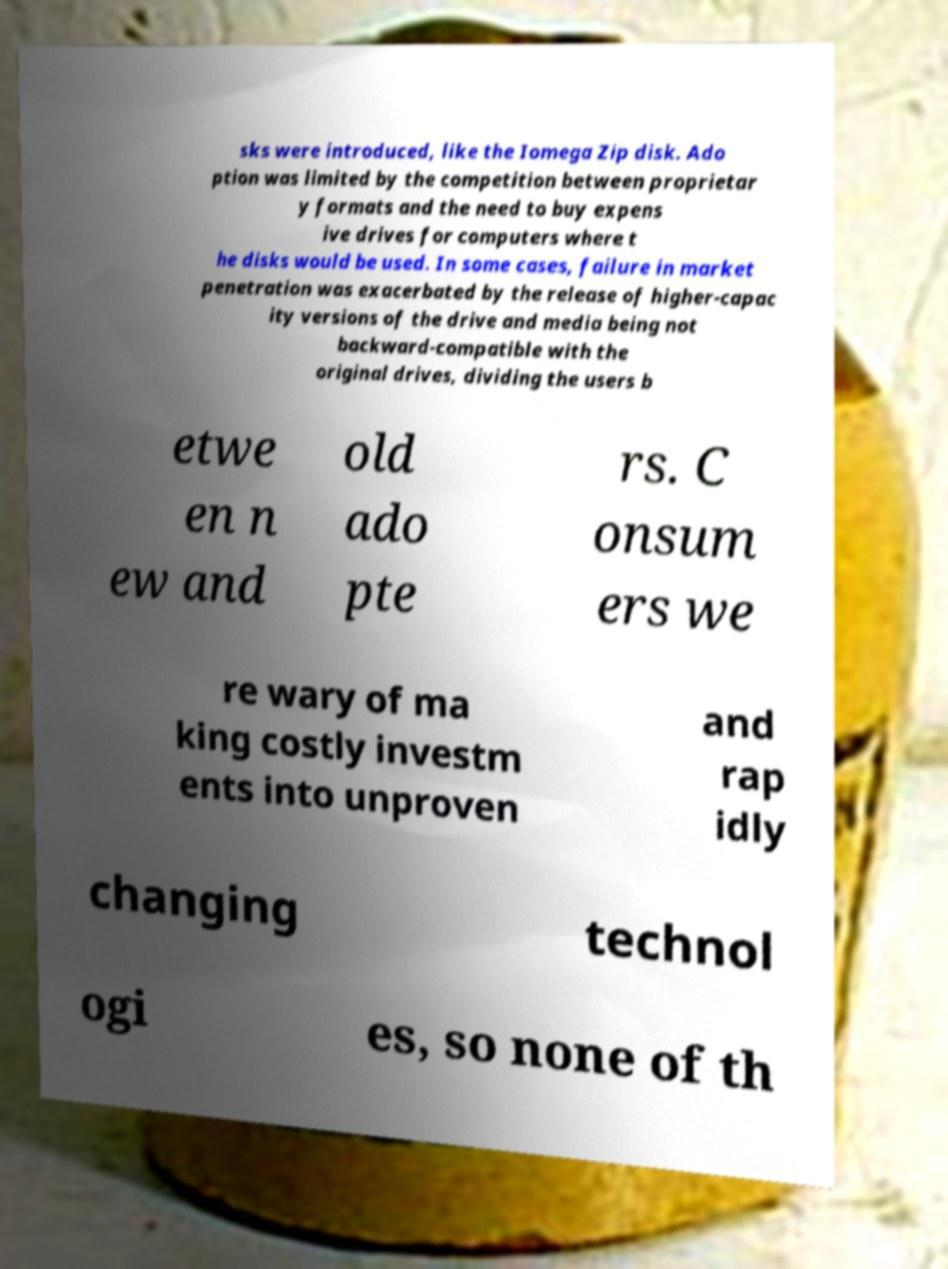There's text embedded in this image that I need extracted. Can you transcribe it verbatim? sks were introduced, like the Iomega Zip disk. Ado ption was limited by the competition between proprietar y formats and the need to buy expens ive drives for computers where t he disks would be used. In some cases, failure in market penetration was exacerbated by the release of higher-capac ity versions of the drive and media being not backward-compatible with the original drives, dividing the users b etwe en n ew and old ado pte rs. C onsum ers we re wary of ma king costly investm ents into unproven and rap idly changing technol ogi es, so none of th 